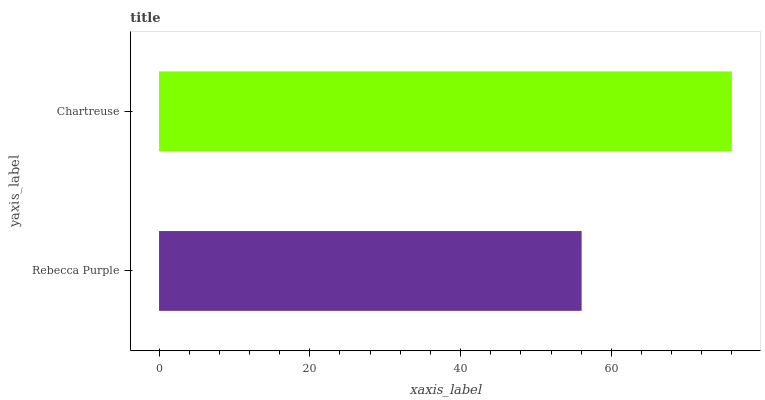Is Rebecca Purple the minimum?
Answer yes or no. Yes. Is Chartreuse the maximum?
Answer yes or no. Yes. Is Chartreuse the minimum?
Answer yes or no. No. Is Chartreuse greater than Rebecca Purple?
Answer yes or no. Yes. Is Rebecca Purple less than Chartreuse?
Answer yes or no. Yes. Is Rebecca Purple greater than Chartreuse?
Answer yes or no. No. Is Chartreuse less than Rebecca Purple?
Answer yes or no. No. Is Chartreuse the high median?
Answer yes or no. Yes. Is Rebecca Purple the low median?
Answer yes or no. Yes. Is Rebecca Purple the high median?
Answer yes or no. No. Is Chartreuse the low median?
Answer yes or no. No. 